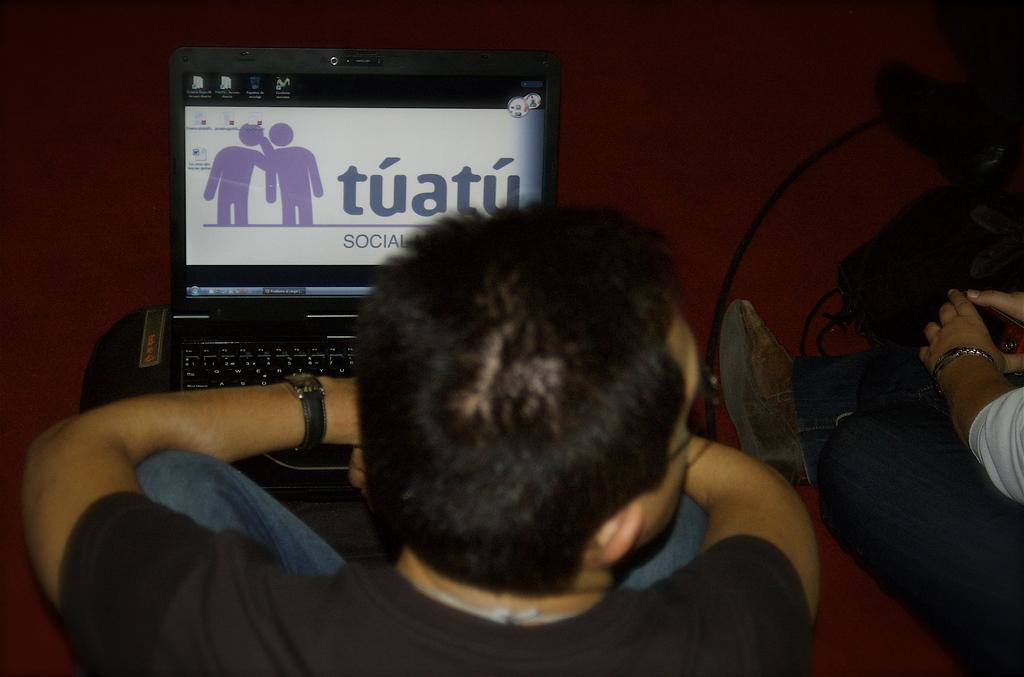What does the big word say on the screen?
Your response must be concise. Tuatu. What is the word under the one in big font?
Give a very brief answer. Social. 